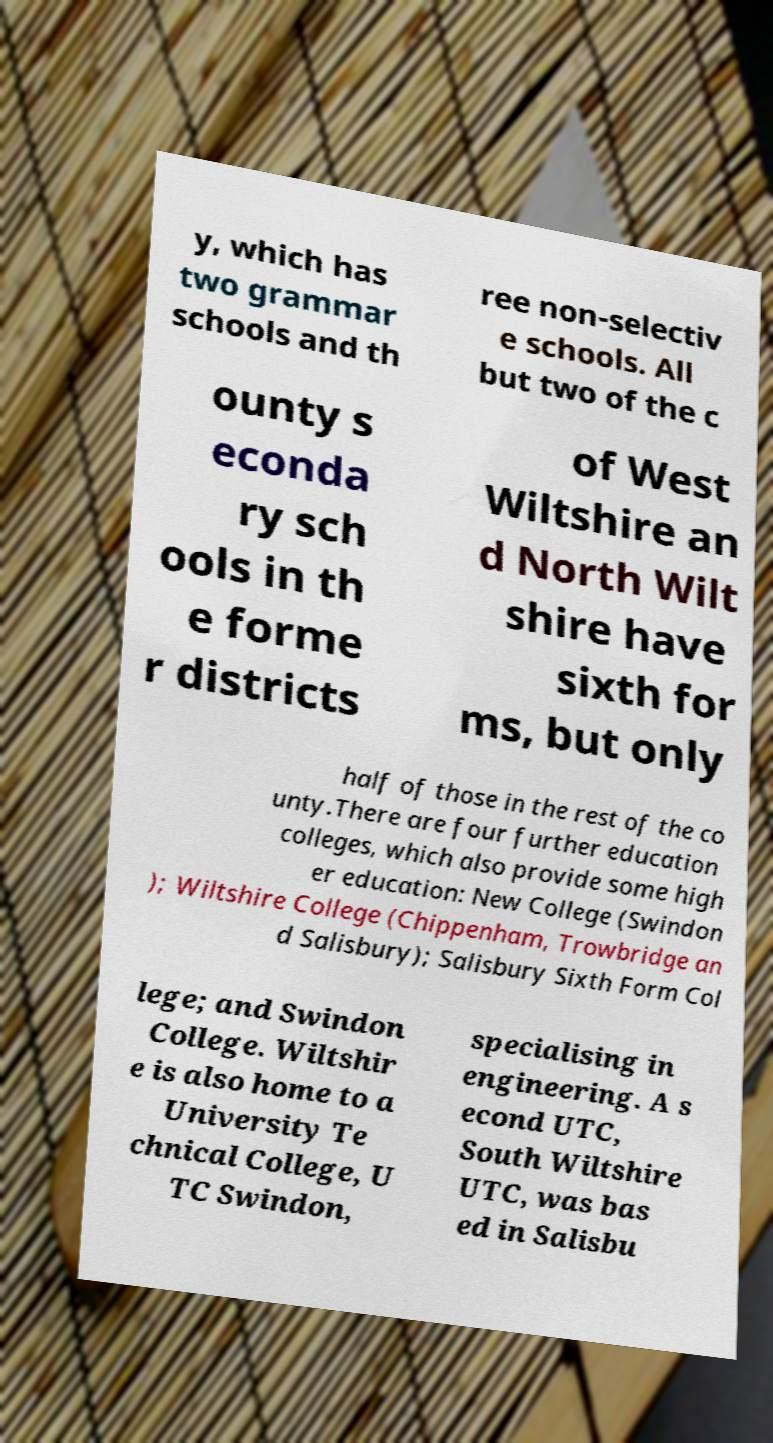For documentation purposes, I need the text within this image transcribed. Could you provide that? y, which has two grammar schools and th ree non-selectiv e schools. All but two of the c ounty s econda ry sch ools in th e forme r districts of West Wiltshire an d North Wilt shire have sixth for ms, but only half of those in the rest of the co unty.There are four further education colleges, which also provide some high er education: New College (Swindon ); Wiltshire College (Chippenham, Trowbridge an d Salisbury); Salisbury Sixth Form Col lege; and Swindon College. Wiltshir e is also home to a University Te chnical College, U TC Swindon, specialising in engineering. A s econd UTC, South Wiltshire UTC, was bas ed in Salisbu 